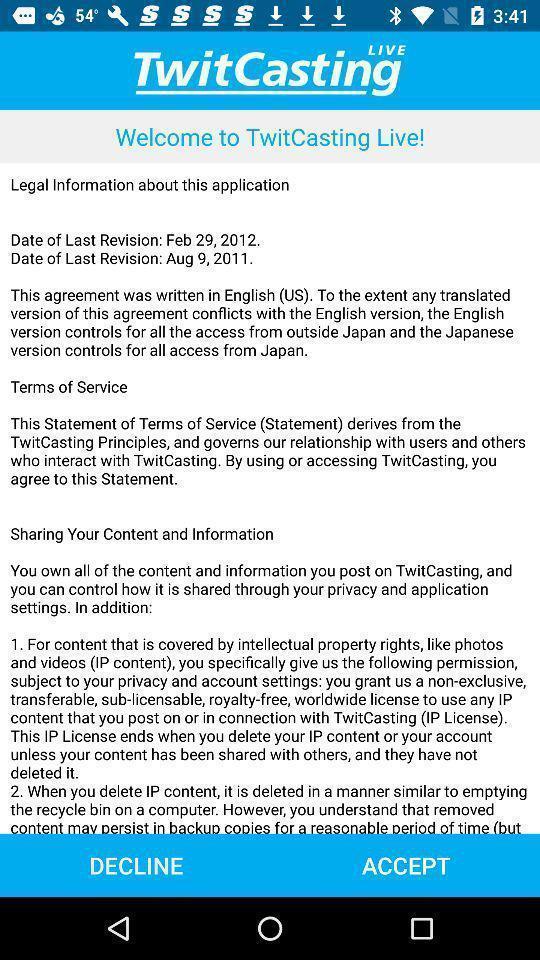Tell me what you see in this picture. Welcome page. 